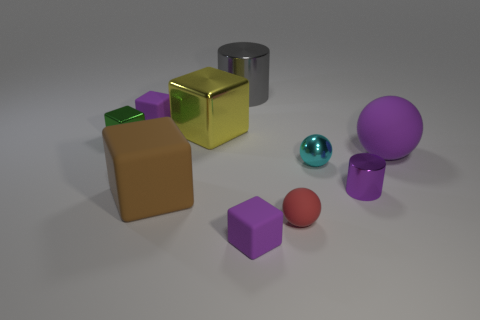Subtract all big shiny cubes. How many cubes are left? 4 Subtract 1 balls. How many balls are left? 2 Subtract all gray cylinders. How many cylinders are left? 1 Subtract all cylinders. How many objects are left? 8 Subtract all cyan cylinders. Subtract all small metallic cubes. How many objects are left? 9 Add 2 large shiny blocks. How many large shiny blocks are left? 3 Add 2 cyan cubes. How many cyan cubes exist? 2 Subtract 1 purple blocks. How many objects are left? 9 Subtract all brown balls. Subtract all brown cylinders. How many balls are left? 3 Subtract all yellow cylinders. How many brown blocks are left? 1 